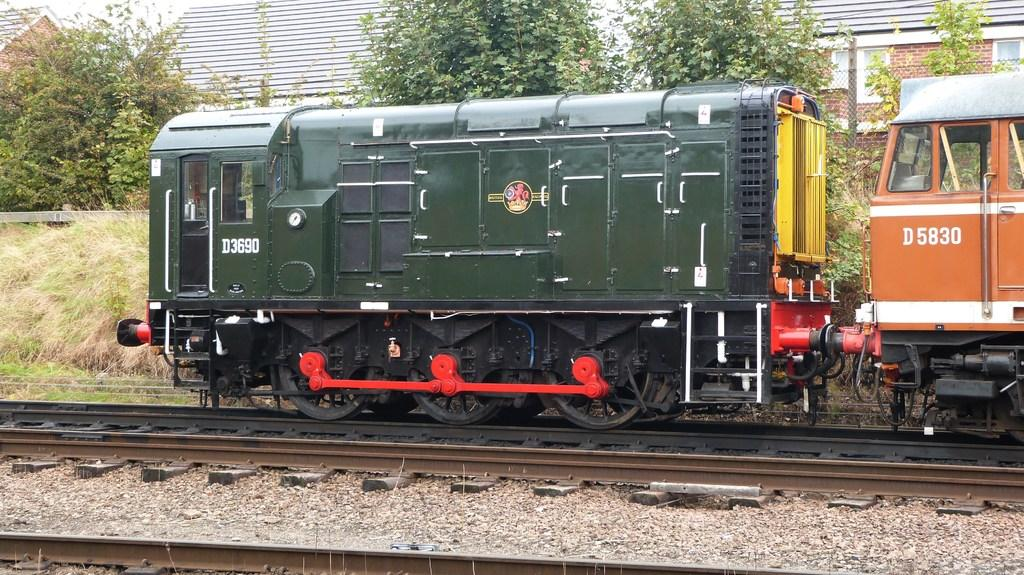<image>
Present a compact description of the photo's key features. A green locomotive with D3690 as the numbers goes down the tracks. 